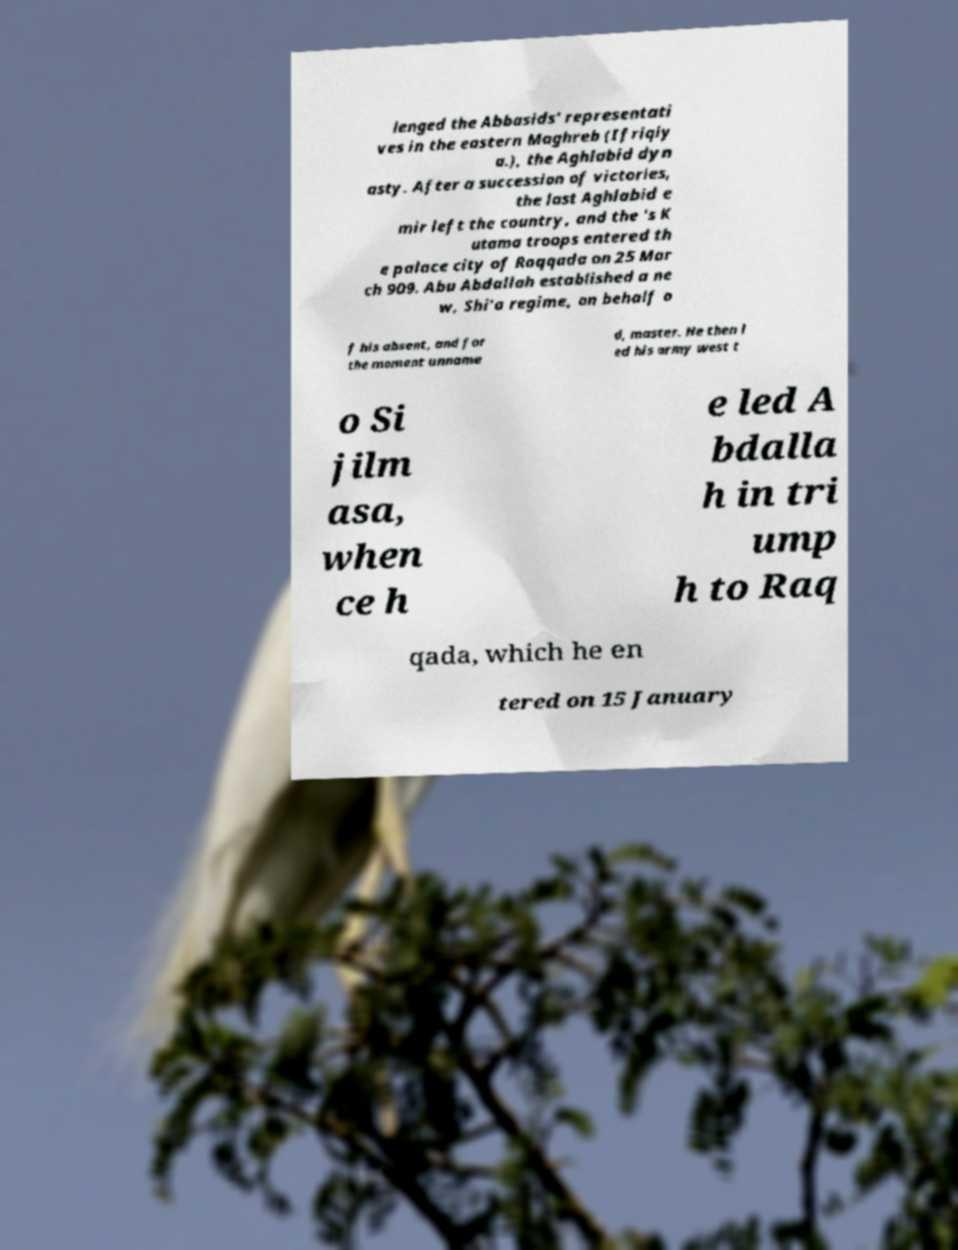Please identify and transcribe the text found in this image. lenged the Abbasids' representati ves in the eastern Maghreb (Ifriqiy a.), the Aghlabid dyn asty. After a succession of victories, the last Aghlabid e mir left the country, and the 's K utama troops entered th e palace city of Raqqada on 25 Mar ch 909. Abu Abdallah established a ne w, Shi'a regime, on behalf o f his absent, and for the moment unname d, master. He then l ed his army west t o Si jilm asa, when ce h e led A bdalla h in tri ump h to Raq qada, which he en tered on 15 January 